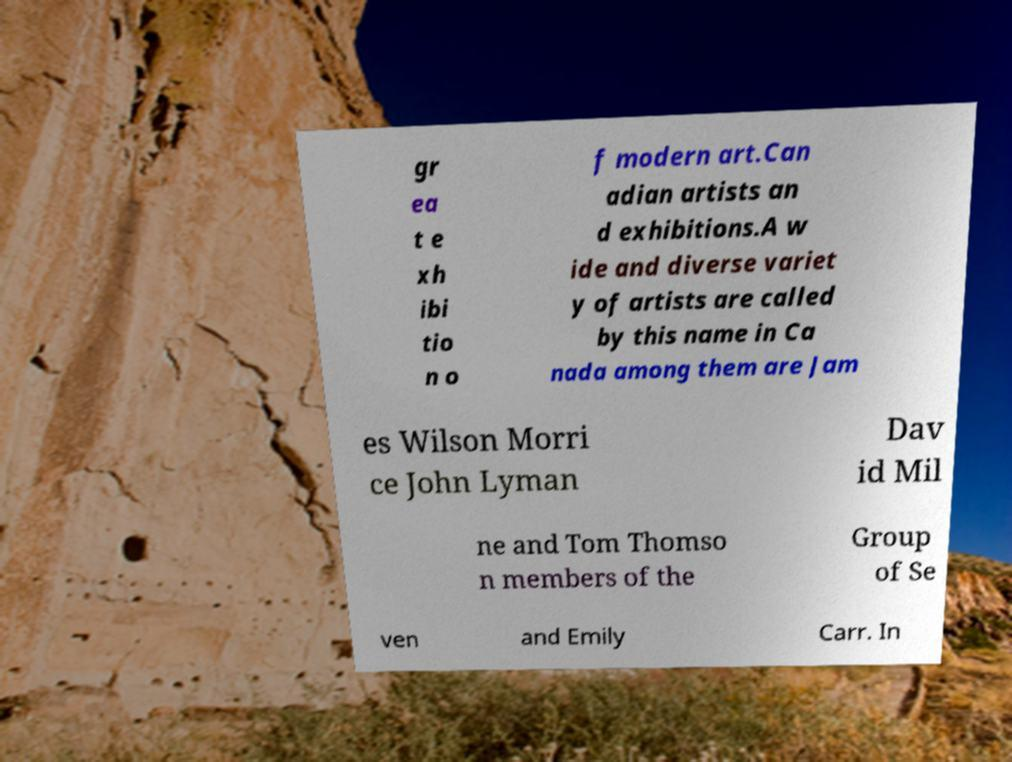There's text embedded in this image that I need extracted. Can you transcribe it verbatim? gr ea t e xh ibi tio n o f modern art.Can adian artists an d exhibitions.A w ide and diverse variet y of artists are called by this name in Ca nada among them are Jam es Wilson Morri ce John Lyman Dav id Mil ne and Tom Thomso n members of the Group of Se ven and Emily Carr. In 